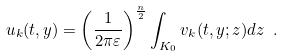Convert formula to latex. <formula><loc_0><loc_0><loc_500><loc_500>u _ { k } ( t , y ) = \left ( \frac { 1 } { 2 \pi \varepsilon } \right ) ^ { \frac { n } { 2 } } \int _ { K _ { 0 } } v _ { k } ( t , y ; z ) d z \ .</formula> 